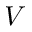<formula> <loc_0><loc_0><loc_500><loc_500>V</formula> 